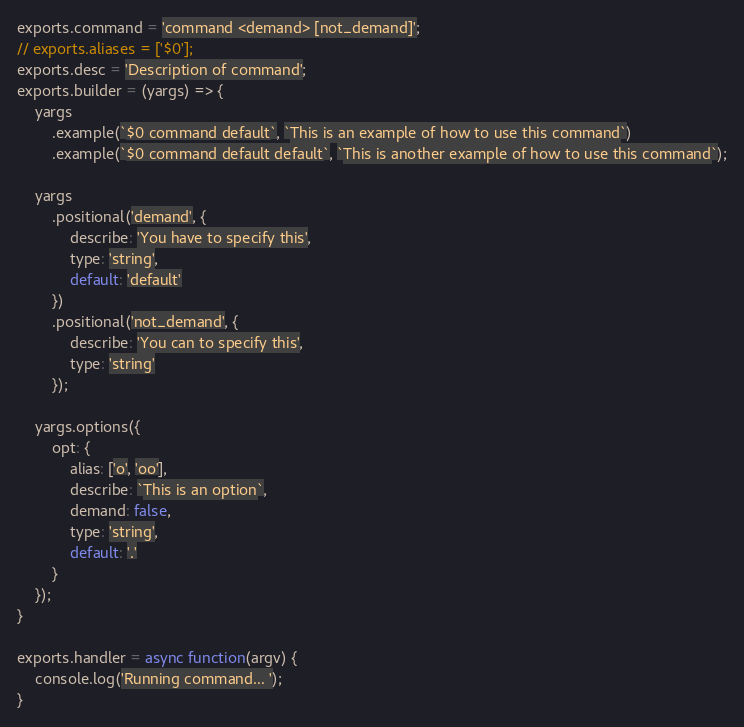<code> <loc_0><loc_0><loc_500><loc_500><_JavaScript_>exports.command = 'command <demand> [not_demand]';
// exports.aliases = ['$0'];
exports.desc = 'Description of command';
exports.builder = (yargs) => {
    yargs
        .example(`$0 command default`, `This is an example of how to use this command`)
        .example(`$0 command default default`, `This is another example of how to use this command`);

    yargs
        .positional('demand', {
            describe: 'You have to specify this',
            type: 'string',
            default: 'default'
        })
        .positional('not_demand', {
            describe: 'You can to specify this',
            type: 'string'
        });

    yargs.options({
        opt: {
            alias: ['o', 'oo'],
            describe: `This is an option`,
            demand: false,
            type: 'string',
            default: '.'
        }
    });
}

exports.handler = async function(argv) {
    console.log('Running command... ');
}
</code> 